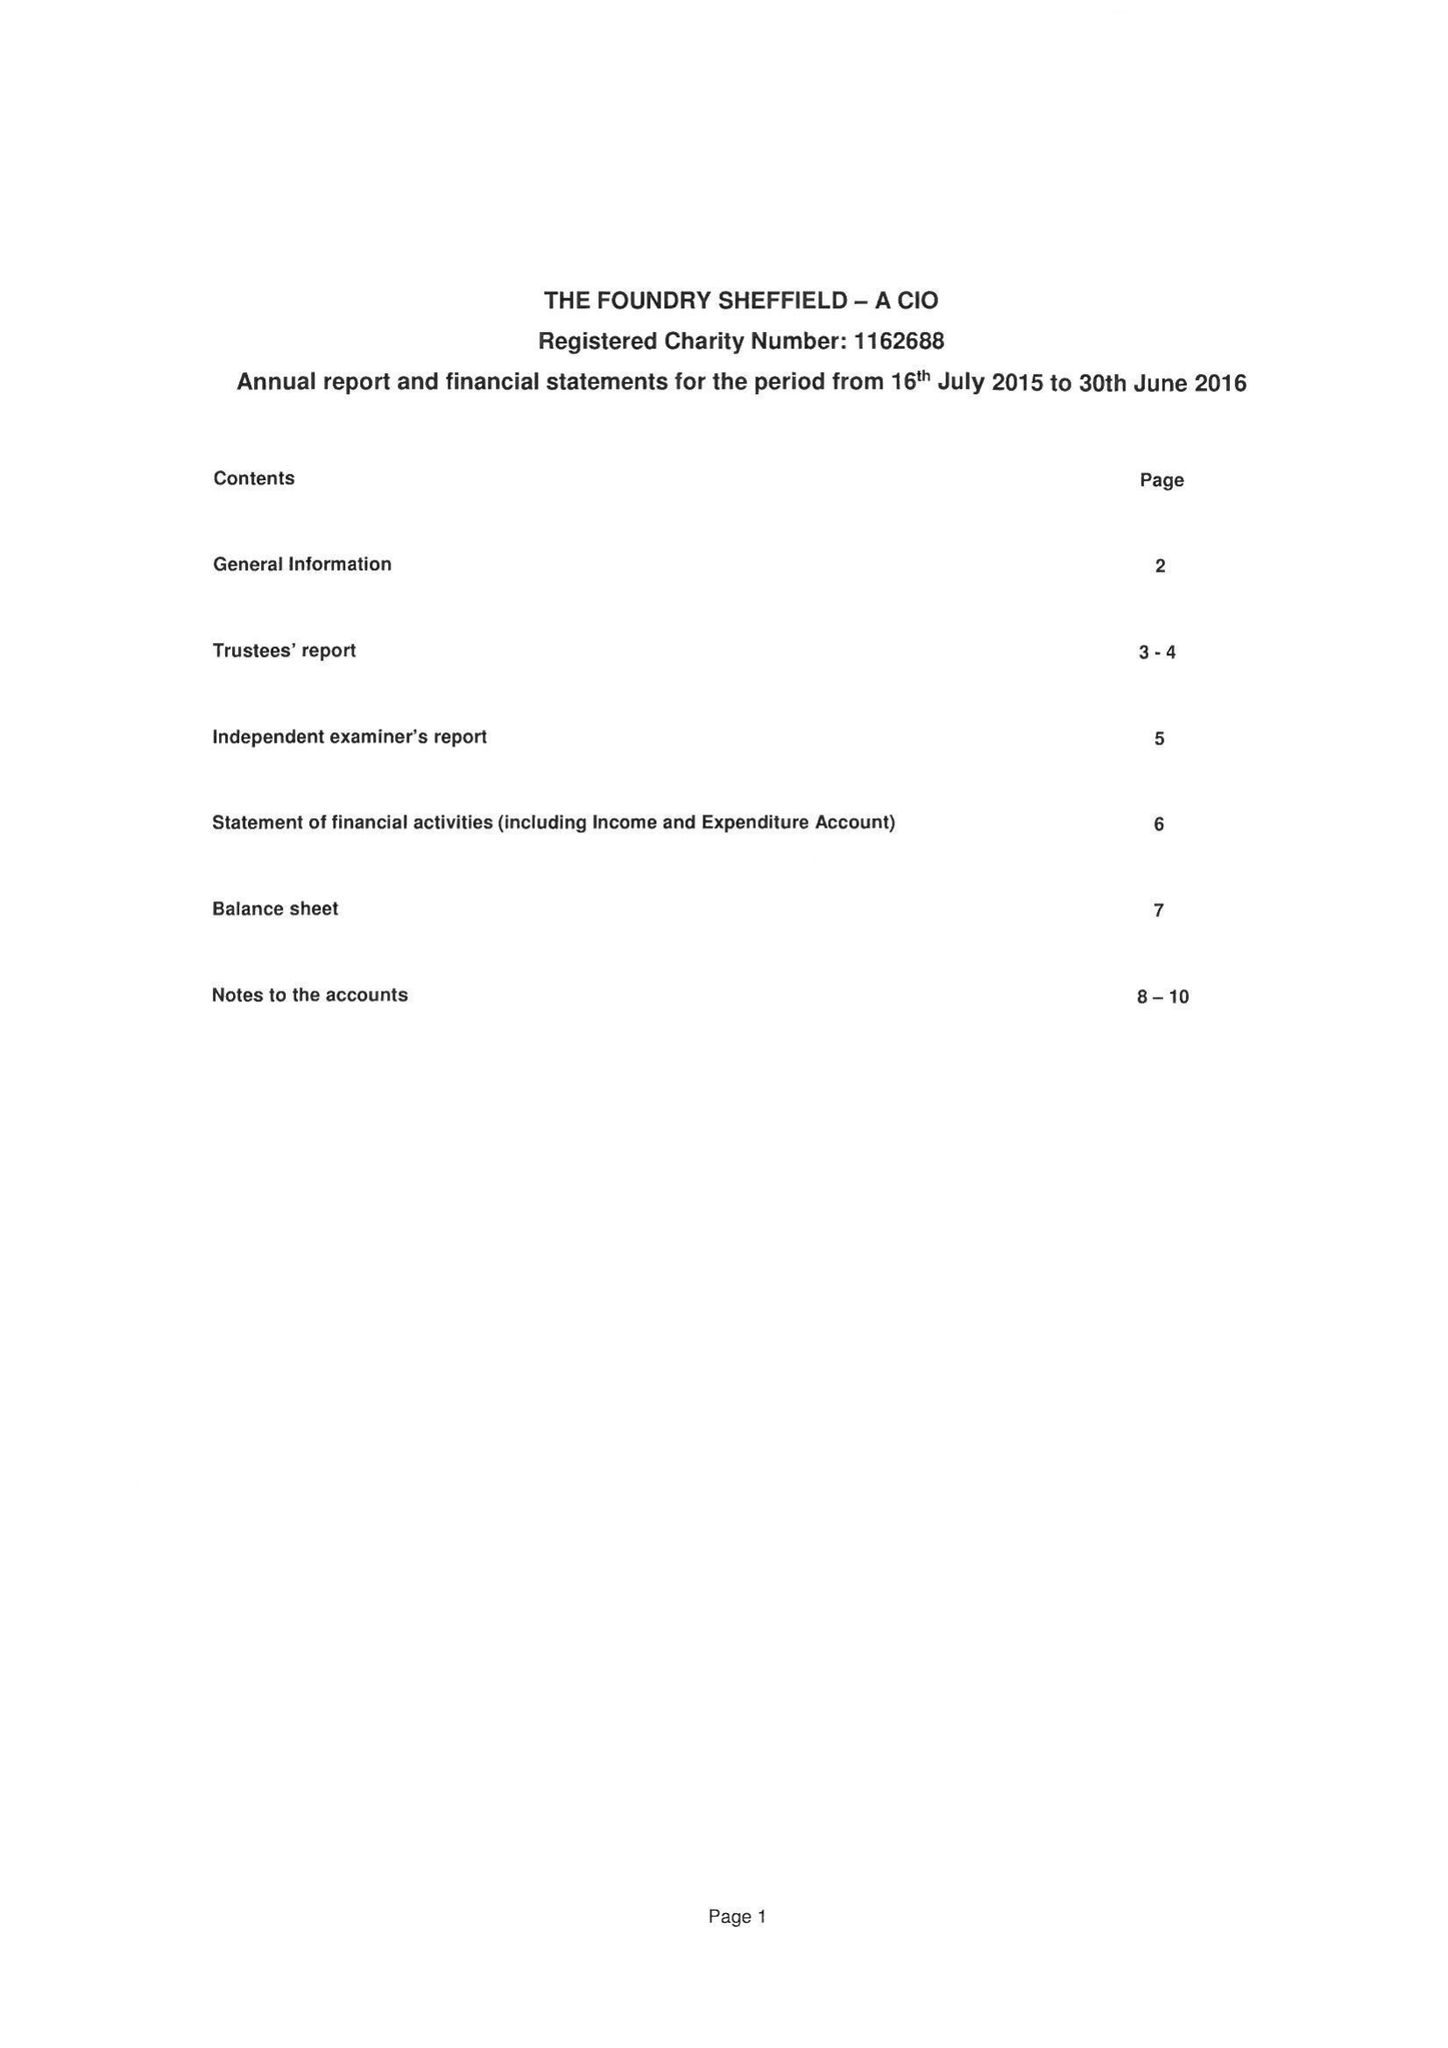What is the value for the charity_number?
Answer the question using a single word or phrase. 1162688 